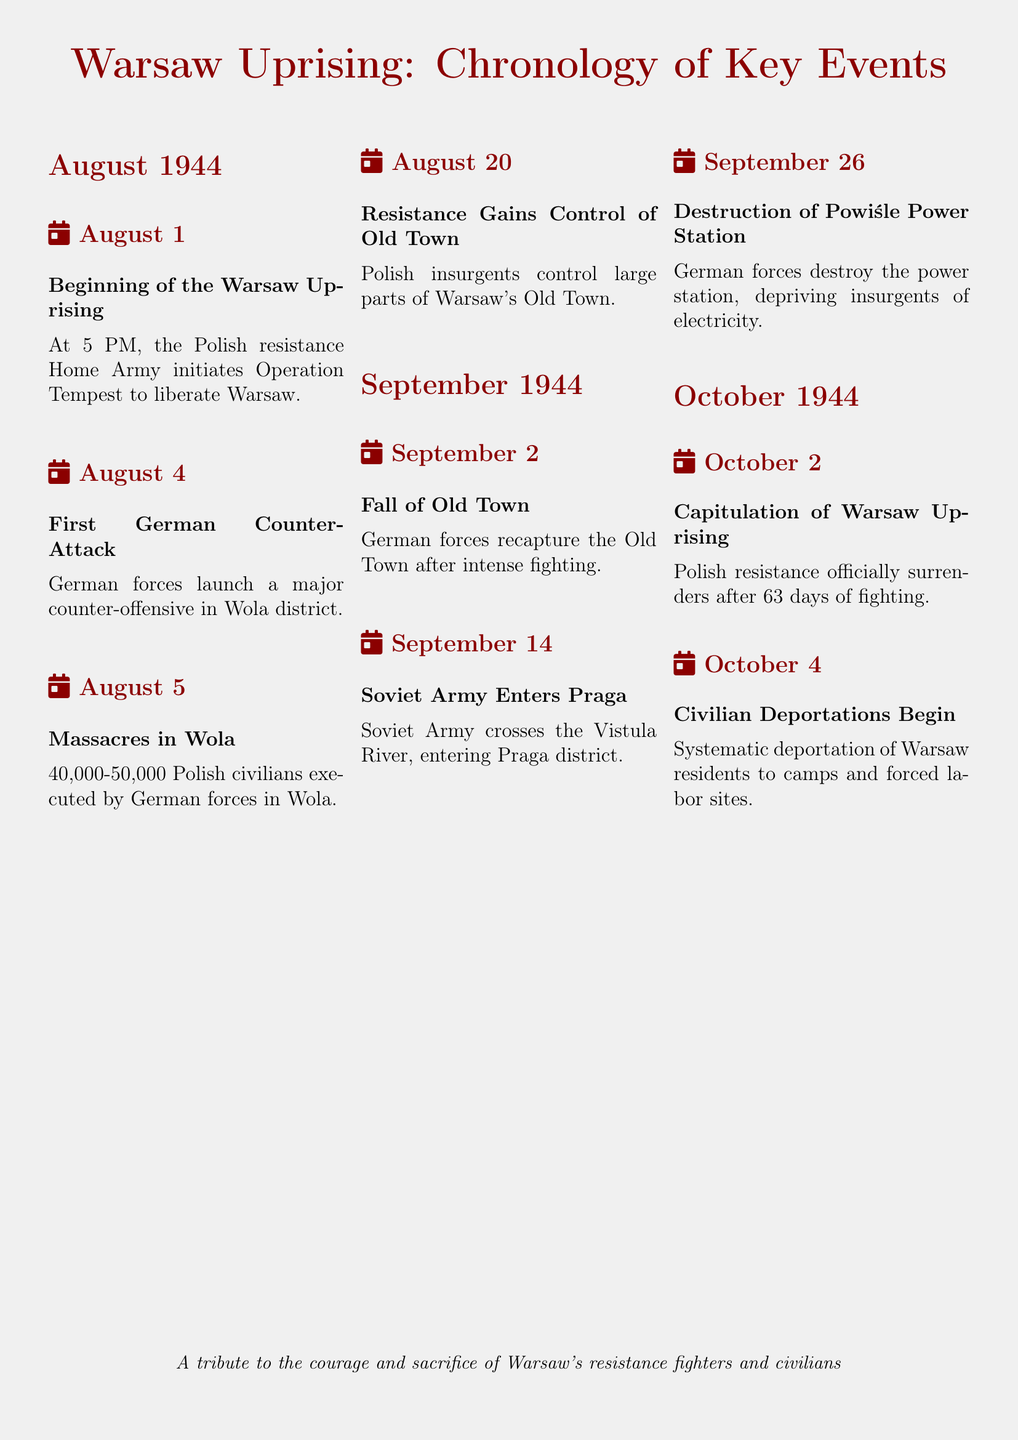what was the date the Warsaw Uprising began? The document specifies that the Warsaw Uprising began on August 1, 1944.
Answer: August 1 how many days did the Warsaw Uprising last? The document states that the Uprising lasted for 63 days before the capitulation.
Answer: 63 days what event occurred on August 5, 1944? The document notes that on this date, 40,000-50,000 Polish civilians were executed in Wola.
Answer: Massacres in Wola which district did the Soviet Army enter on September 14, 1944? The document indicates that the Soviet Army entered the Praga district on this date.
Answer: Praga when did the Polish resistance officially surrender? According to the document, the capitulation of the Warsaw Uprising took place on October 2, 1944.
Answer: October 2 what significant destruction occurred on September 26, 1944? The document mentions that the German forces destroyed the Powiśle Power Station on this date.
Answer: Destruction of Powiśle Power Station what was the main action of the Polish Home Army at the beginning of the Uprising? The document states that the Polish resistance Home Army initiated Operation Tempest to liberate Warsaw.
Answer: Operation Tempest how many Polish civilians were executed during the massacres in Wola? The document provides an estimate of 40,000-50,000 Polish civilians executed by German forces in Wola.
Answer: 40,000-50,000 what is the last key event listed in the document? The document specifies that the last key event listed is the systematic deportation of Warsaw residents on October 4, 1944.
Answer: Civilian Deportations Begin 